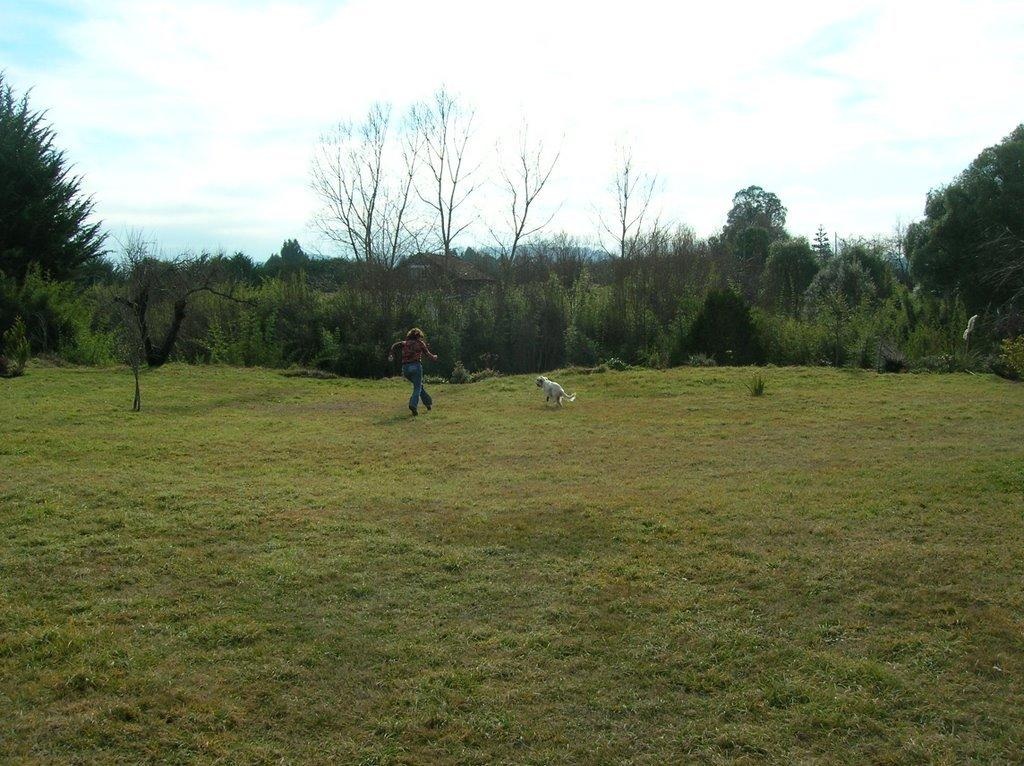How many individuals are present in the image? There is one person in the image. What other living creature is present in the image? There is a dog in the image. Where are the person and dog located? They are on a grassy land in the image. What can be seen in the background of the image? There are trees in the background of the image. What is visible at the top of the image? The sky is visible at the top of the image. What type of furniture can be seen in the image? There is no furniture present in the image. What time does the clock show in the image? There is no clock present in the image. 